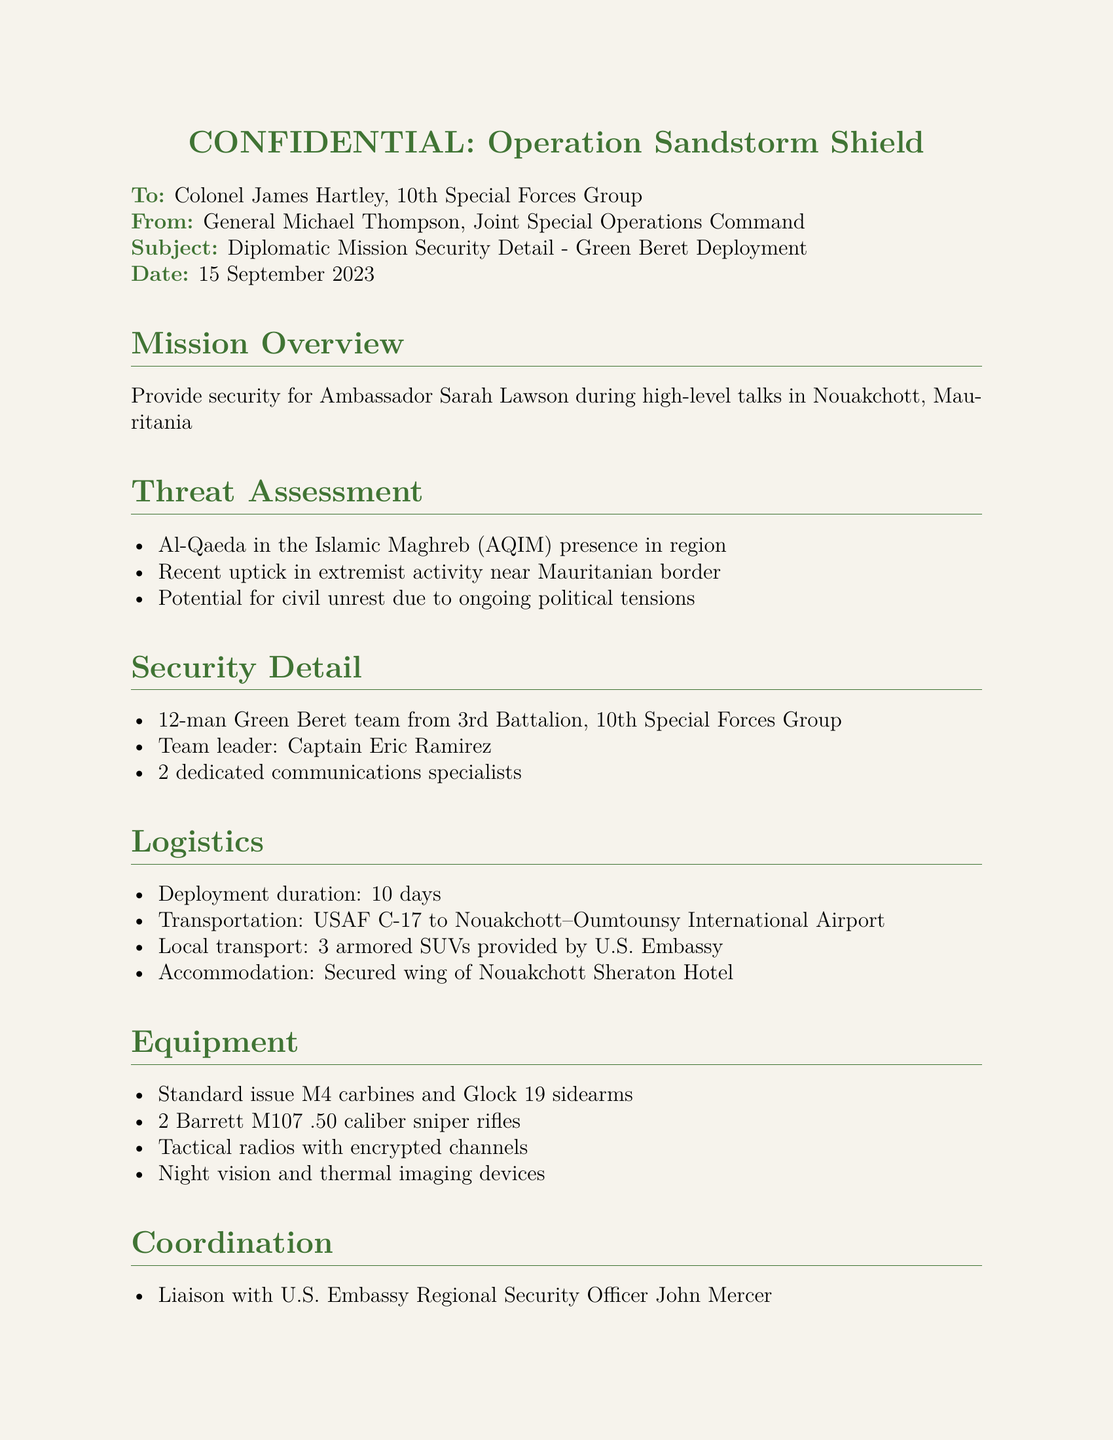What is the date of the document? The date of the document is specified in the header of the fax.
Answer: 15 September 2023 Who is the team leader for the security detail? The document directly states the name of the team leader responsible for the Green Beret security detail.
Answer: Captain Eric Ramirez How many members are in the Green Beret team? The number of personnel in the Green Beret team is stated in the security detail section of the document.
Answer: 12-man What type of transport will be used for deployment? The document mentions the type of military aircraft designated for the mission's transportation.
Answer: USAF C-17 What is the deployment duration? The deployment length is noted in the logistics section of the document.
Answer: 10 days What is the primary threat mentioned? The primary threat identified in the threat assessment section is an active militant group operating in the area.
Answer: Al-Qaeda in the Islamic Maghreb (AQIM) How many sniper rifles are included in the equipment list? The document lists the number of sniper rifles that will be part of the equipment for the mission.
Answer: 2 Who will provide outer perimeter security? The coordination section of the document mentions the organization responsible for security on the perimeter of the mission area.
Answer: Mauritanian Gendarmerie 